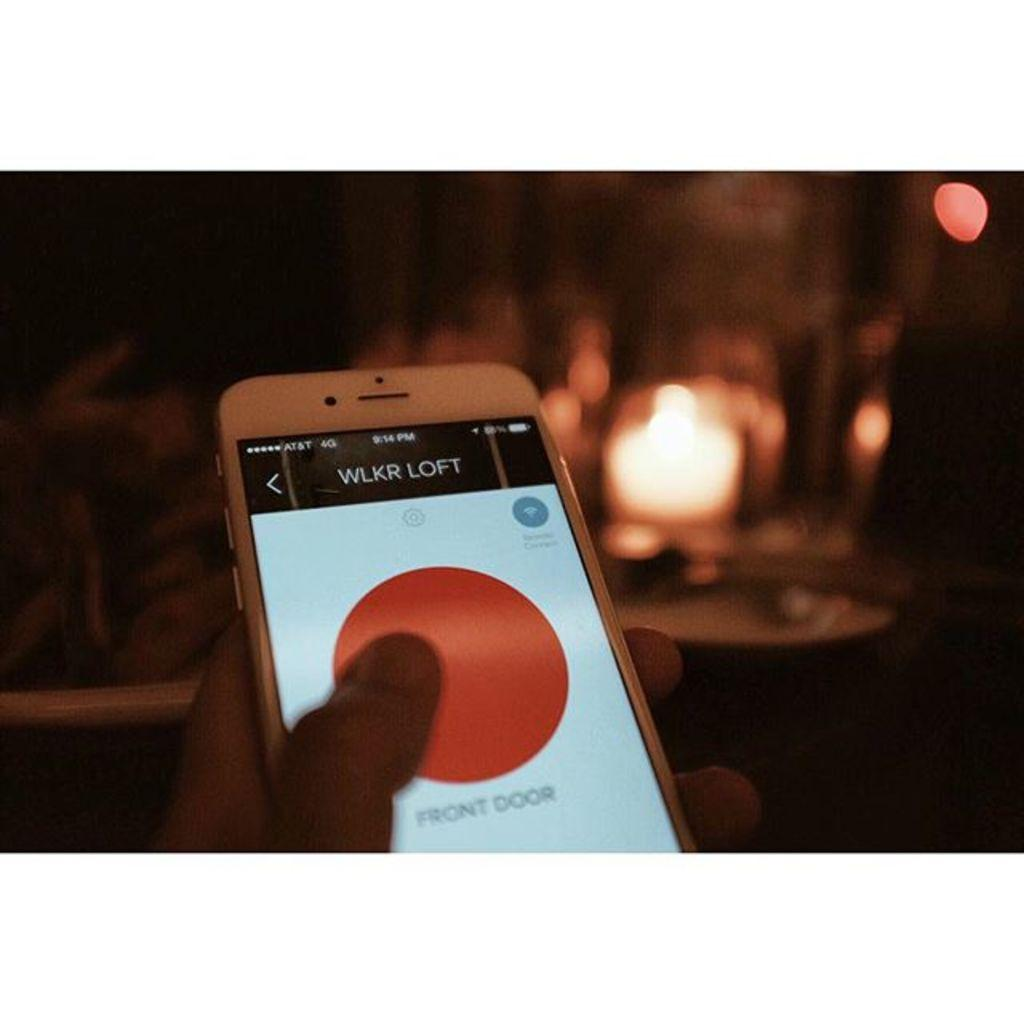<image>
Render a clear and concise summary of the photo. An AT&T phone open to a smart home app that locks and unlocks the front door. 